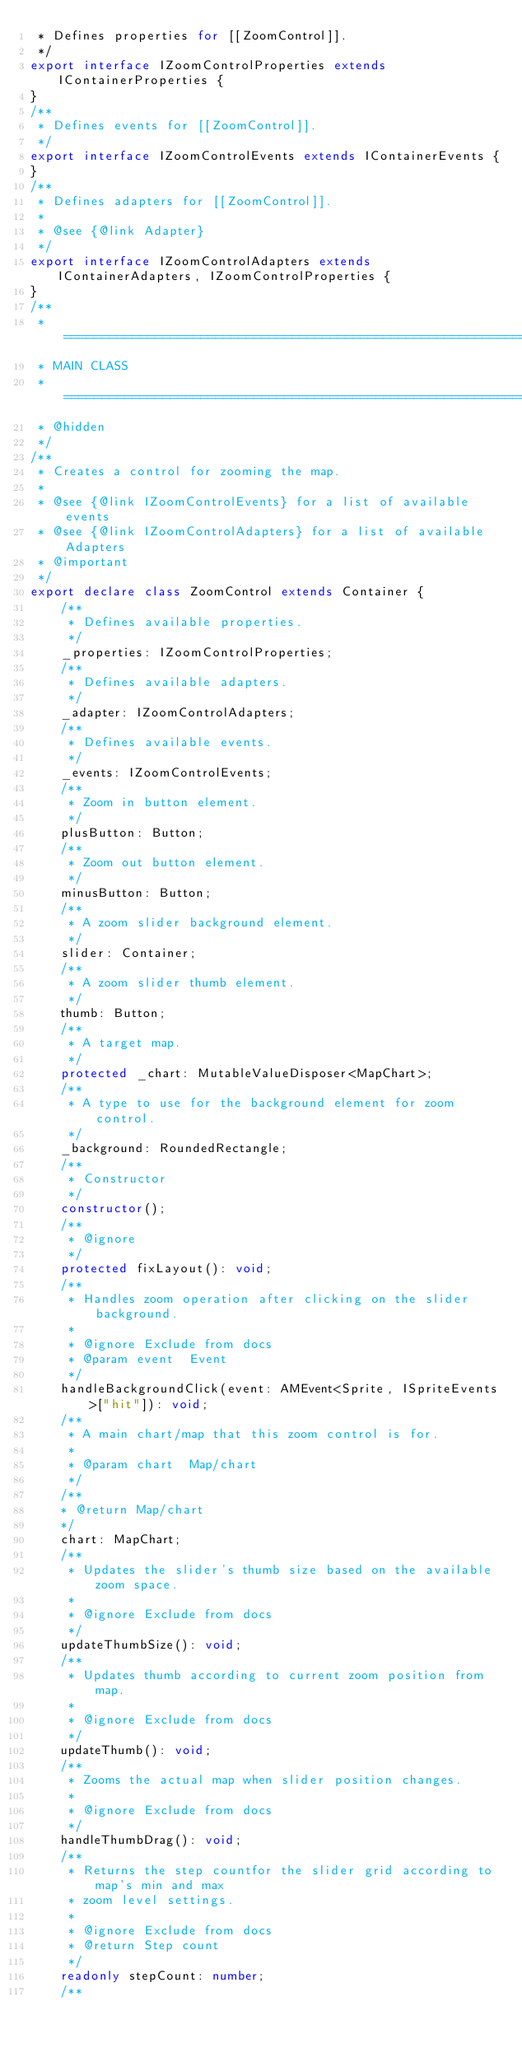Convert code to text. <code><loc_0><loc_0><loc_500><loc_500><_TypeScript_> * Defines properties for [[ZoomControl]].
 */
export interface IZoomControlProperties extends IContainerProperties {
}
/**
 * Defines events for [[ZoomControl]].
 */
export interface IZoomControlEvents extends IContainerEvents {
}
/**
 * Defines adapters for [[ZoomControl]].
 *
 * @see {@link Adapter}
 */
export interface IZoomControlAdapters extends IContainerAdapters, IZoomControlProperties {
}
/**
 * ============================================================================
 * MAIN CLASS
 * ============================================================================
 * @hidden
 */
/**
 * Creates a control for zooming the map.
 *
 * @see {@link IZoomControlEvents} for a list of available events
 * @see {@link IZoomControlAdapters} for a list of available Adapters
 * @important
 */
export declare class ZoomControl extends Container {
    /**
     * Defines available properties.
     */
    _properties: IZoomControlProperties;
    /**
     * Defines available adapters.
     */
    _adapter: IZoomControlAdapters;
    /**
     * Defines available events.
     */
    _events: IZoomControlEvents;
    /**
     * Zoom in button element.
     */
    plusButton: Button;
    /**
     * Zoom out button element.
     */
    minusButton: Button;
    /**
     * A zoom slider background element.
     */
    slider: Container;
    /**
     * A zoom slider thumb element.
     */
    thumb: Button;
    /**
     * A target map.
     */
    protected _chart: MutableValueDisposer<MapChart>;
    /**
     * A type to use for the background element for zoom control.
     */
    _background: RoundedRectangle;
    /**
     * Constructor
     */
    constructor();
    /**
     * @ignore
     */
    protected fixLayout(): void;
    /**
     * Handles zoom operation after clicking on the slider background.
     *
     * @ignore Exclude from docs
     * @param event  Event
     */
    handleBackgroundClick(event: AMEvent<Sprite, ISpriteEvents>["hit"]): void;
    /**
     * A main chart/map that this zoom control is for.
     *
     * @param chart  Map/chart
     */
    /**
    * @return Map/chart
    */
    chart: MapChart;
    /**
     * Updates the slider's thumb size based on the available zoom space.
     *
     * @ignore Exclude from docs
     */
    updateThumbSize(): void;
    /**
     * Updates thumb according to current zoom position from map.
     *
     * @ignore Exclude from docs
     */
    updateThumb(): void;
    /**
     * Zooms the actual map when slider position changes.
     *
     * @ignore Exclude from docs
     */
    handleThumbDrag(): void;
    /**
     * Returns the step countfor the slider grid according to map's min and max
     * zoom level settings.
     *
     * @ignore Exclude from docs
     * @return Step count
     */
    readonly stepCount: number;
    /**</code> 